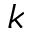<formula> <loc_0><loc_0><loc_500><loc_500>k</formula> 